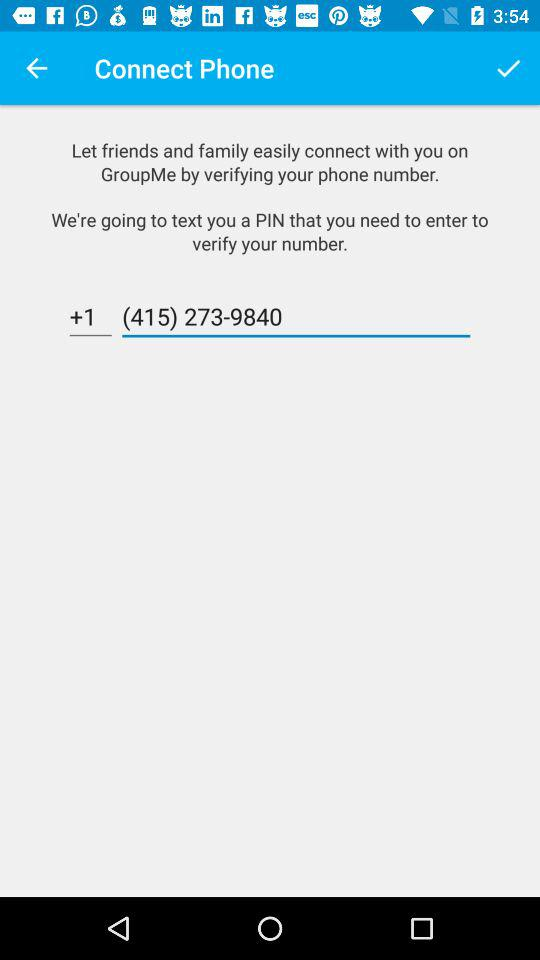How many digits are in the phone number in the second text input field?
Answer the question using a single word or phrase. 10 